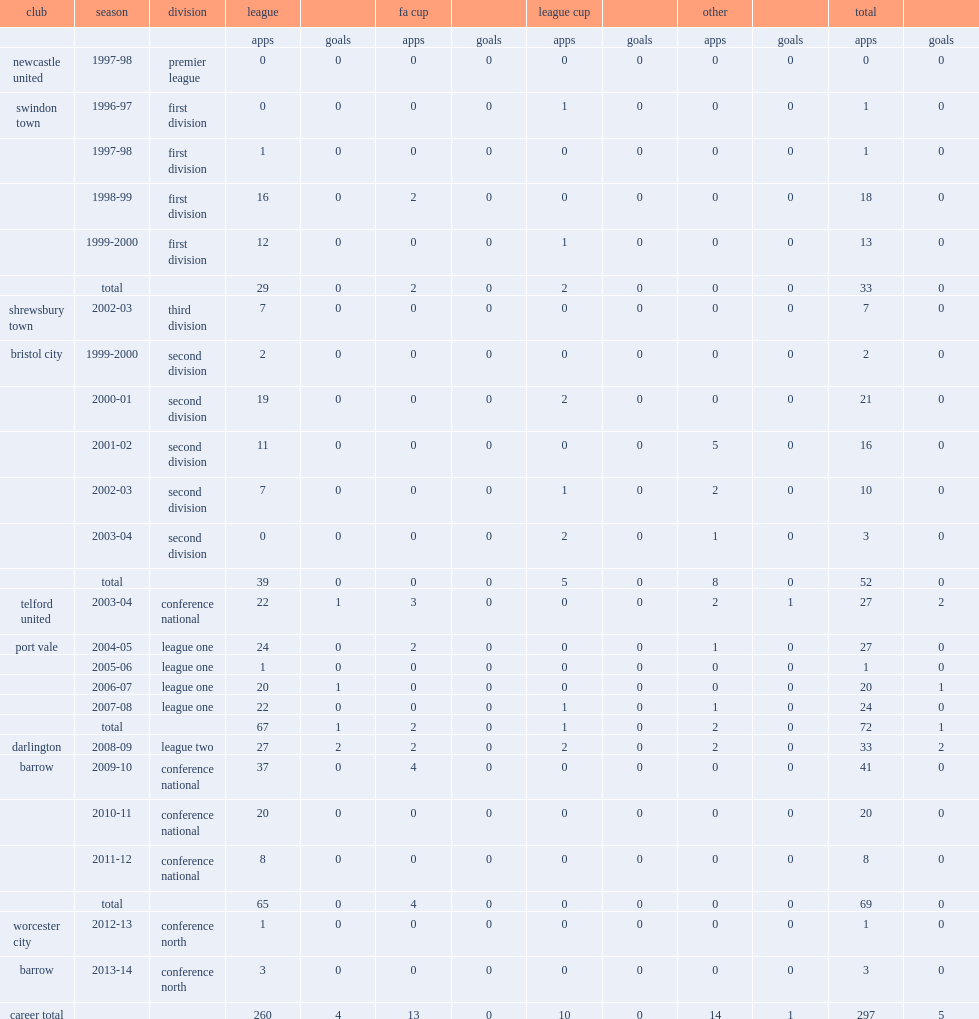In 2008-09, how many games did robin hulbert play for the league two side darlington? 33.0. 